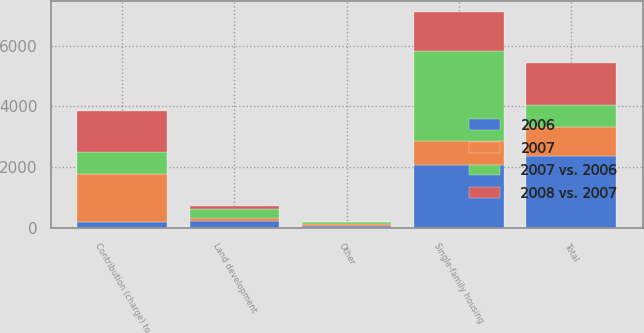<chart> <loc_0><loc_0><loc_500><loc_500><stacked_bar_chart><ecel><fcel>Single-family housing<fcel>Land development<fcel>Other<fcel>Total<fcel>Contribution (charge) to<nl><fcel>2008 vs. 2007<fcel>1294<fcel>99<fcel>15<fcel>1408<fcel>1357<nl><fcel>2006<fcel>2079<fcel>213<fcel>67<fcel>2359<fcel>204<nl><fcel>2007 vs. 2006<fcel>2951<fcel>310<fcel>74<fcel>723<fcel>723<nl><fcel>2007<fcel>785<fcel>114<fcel>52<fcel>951<fcel>1561<nl></chart> 